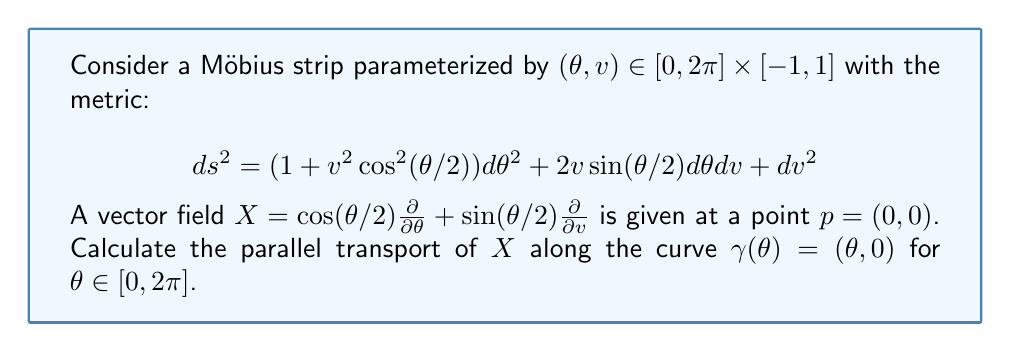Help me with this question. To solve this problem, we'll follow these steps:

1) First, we need to calculate the Christoffel symbols for the given metric. The non-zero Christoffel symbols are:

   $$\Gamma^\theta_{\theta\theta} = \frac{v\sin(\theta/2)}{1+v^2\cos^2(\theta/2)}$$
   $$\Gamma^\theta_{\theta v} = \Gamma^\theta_{v\theta} = \frac{v\cos(\theta/2)}{1+v^2\cos^2(\theta/2)}$$
   $$\Gamma^v_{\theta\theta} = -v\cos(\theta/2)$$

2) The parallel transport equation along $\gamma(\theta)$ is:

   $$\frac{dX^\mu}{d\theta} + \Gamma^\mu_{\alpha\beta}\frac{d\gamma^\alpha}{d\theta}X^\beta = 0$$

3) Let $X = a(\theta)\frac{\partial}{\partial \theta} + b(\theta)\frac{\partial}{\partial v}$. We need to solve:

   $$\frac{da}{d\theta} + \Gamma^\theta_{\theta\theta}a = 0$$
   $$\frac{db}{d\theta} + \Gamma^v_{\theta\theta}a = 0$$

4) Along $\gamma(\theta) = (\theta, 0)$, the Christoffel symbols simplify to:

   $$\Gamma^\theta_{\theta\theta} = 0, \quad \Gamma^v_{\theta\theta} = 0$$

5) Therefore, our equations become:

   $$\frac{da}{d\theta} = 0$$
   $$\frac{db}{d\theta} = 0$$

6) This means $a$ and $b$ are constant along $\gamma$. With initial conditions $a(0) = \cos(0) = 1$ and $b(0) = \sin(0) = 0$, we have:

   $$a(\theta) = 1, \quad b(\theta) = 0$$

7) Therefore, the parallel transport of $X$ along $\gamma$ is:

   $$X(\theta) = \frac{\partial}{\partial \theta}$$

8) At $\theta = 2\pi$, we return to the same point on the Möbius strip, but the vector has changed sign:

   $$X(2\pi) = -\frac{\partial}{\partial \theta}$$

This sign change is characteristic of parallel transport on a Möbius strip, reflecting its non-orientability.
Answer: $X(2\pi) = -\frac{\partial}{\partial \theta}$ 